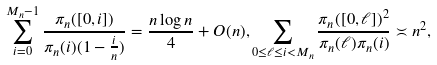Convert formula to latex. <formula><loc_0><loc_0><loc_500><loc_500>\sum _ { i = 0 } ^ { M _ { n } - 1 } \frac { \pi _ { n } ( [ 0 , i ] ) } { \pi _ { n } ( i ) ( 1 - \frac { i } { n } ) } = \frac { n \log n } { 4 } + O ( n ) , \sum _ { 0 \leq \ell \leq i < M _ { n } } \frac { \pi _ { n } ( [ 0 , \ell ] ) ^ { 2 } } { \pi _ { n } ( \ell ) \pi _ { n } ( i ) } \asymp n ^ { 2 } ,</formula> 